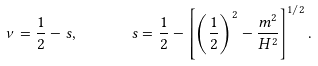<formula> <loc_0><loc_0><loc_500><loc_500>\nu = \frac { 1 } { 2 } - s , \quad \ \ s = \frac { 1 } { 2 } - \left [ \left ( \frac { 1 } { 2 } \right ) ^ { 2 } - \frac { m ^ { 2 } } { H ^ { 2 } } \right ] ^ { 1 / 2 } .</formula> 